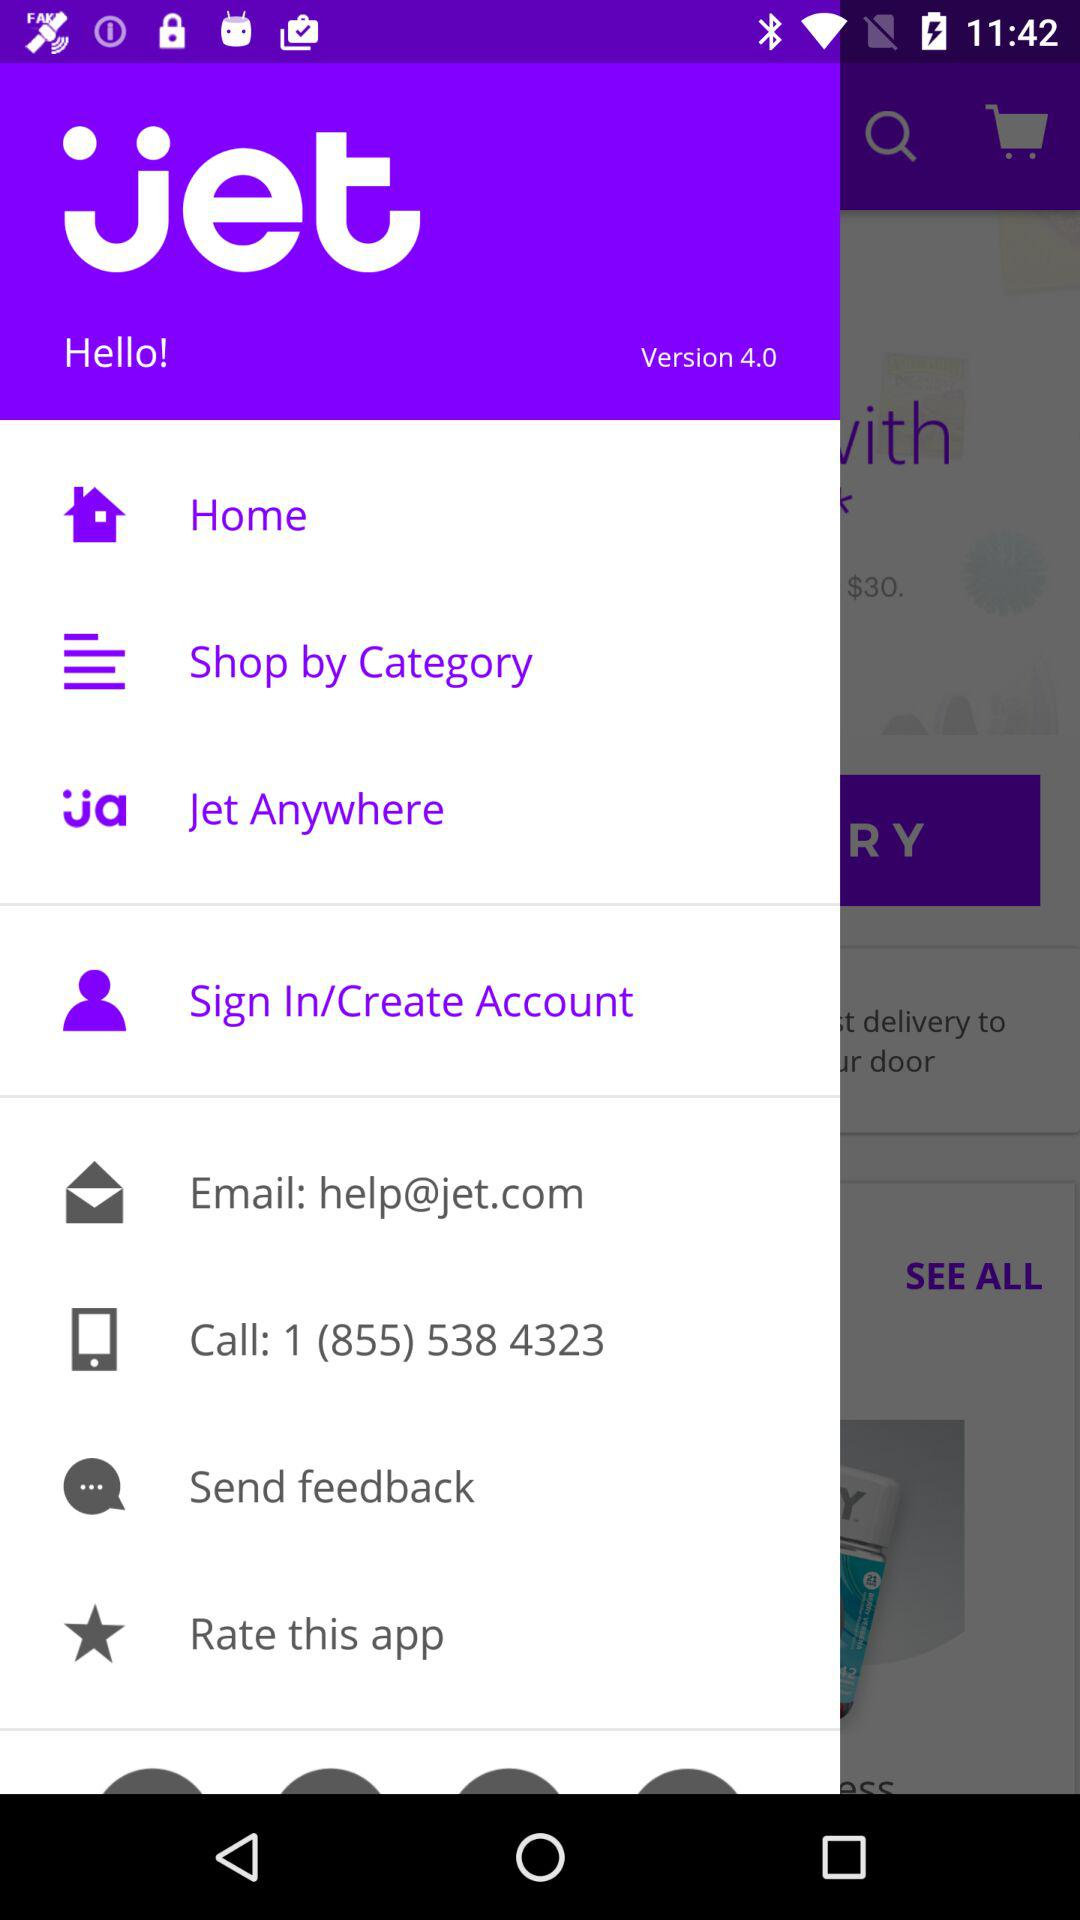What is the application name? The application name is "jet". 